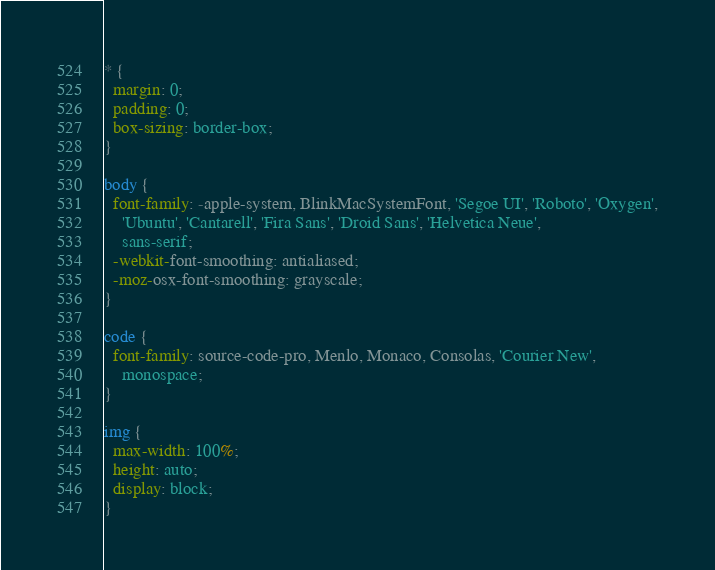<code> <loc_0><loc_0><loc_500><loc_500><_CSS_>* {
  margin: 0;
  padding: 0;
  box-sizing: border-box;
}

body {
  font-family: -apple-system, BlinkMacSystemFont, 'Segoe UI', 'Roboto', 'Oxygen',
    'Ubuntu', 'Cantarell', 'Fira Sans', 'Droid Sans', 'Helvetica Neue',
    sans-serif;
  -webkit-font-smoothing: antialiased;
  -moz-osx-font-smoothing: grayscale;
}

code {
  font-family: source-code-pro, Menlo, Monaco, Consolas, 'Courier New',
    monospace;
}

img {
  max-width: 100%;
  height: auto;
  display: block;
}
</code> 